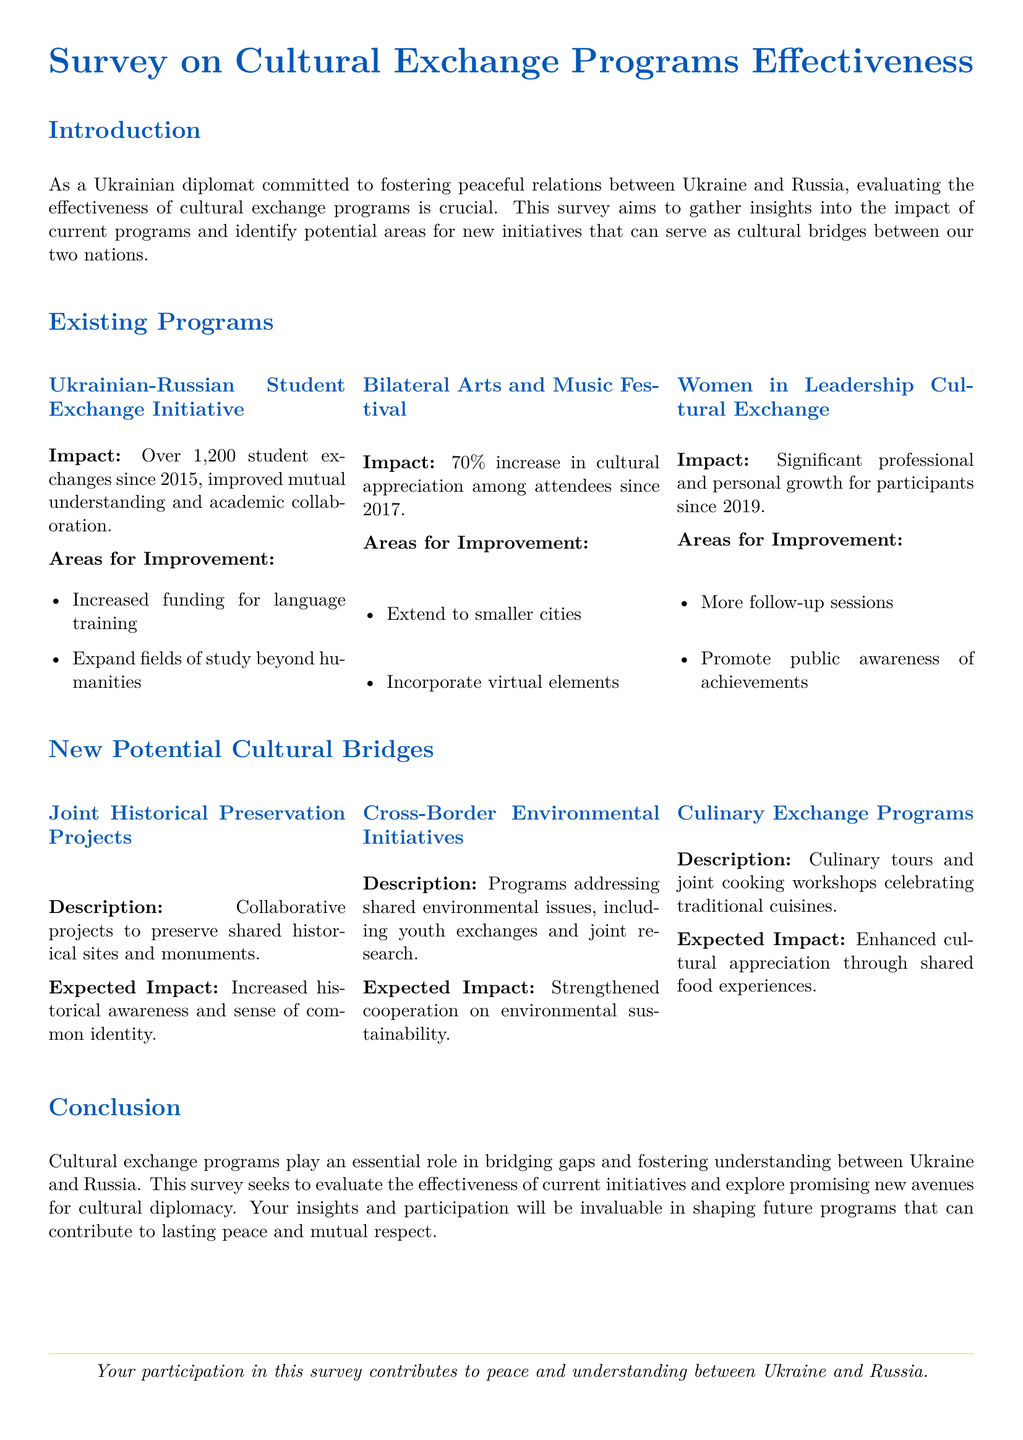What is the title of the survey? The title is mentioned at the top of the document and reflects the subject of the assessment.
Answer: Survey on Cultural Exchange Programs Effectiveness How many student exchanges have occurred since 2015? The document specifies the number of student exchanges that have taken place as part of the initiative.
Answer: Over 1,200 What percentage increase in cultural appreciation is noted for the Bilateral Arts and Music Festival? The document highlights a specific percentage increase in cultural appreciation among attendees.
Answer: 70% What year did the Women in Leadership Cultural Exchange start? The year when the program began is explicitly stated in the document.
Answer: 2019 What is one area for improvement for language training? The document lists specific areas that require enhancement in the programs, including one for language training.
Answer: Increased funding What is a potential new cultural bridge suggested in the document? The document outlines several new initiatives that could act as cultural bridges, and asks for examples.
Answer: Joint Historical Preservation Projects What type of exchange program focuses on food? The document describes different types of exchange programs, and one specifically relates to culinary experiences.
Answer: Culinary Exchange Programs What is the expected impact of Cross-Border Environmental Initiatives? The document mentions the intended outcome of this specific initiative detailed in the proposal.
Answer: Strengthened cooperation on environmental sustainability What do participants contribute to by completing the survey? There is a statement at the end of the document that outlines what participant contributions aim to achieve through their responses.
Answer: Peace and understanding between Ukraine and Russia 